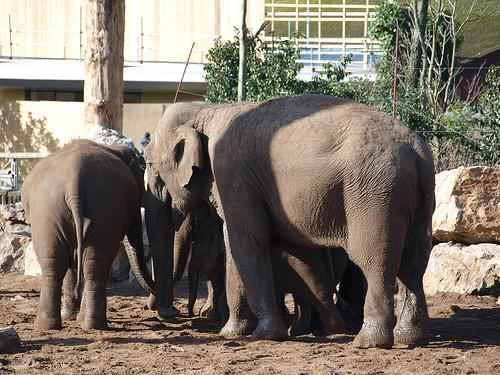Question: what color are the elephants?
Choices:
A. Gray.
B. Silver.
C. White.
D. Brown.
Answer with the letter. Answer: A Question: what type of animals are these?
Choices:
A. Elephants.
B. Dogs.
C. Cats.
D. Tigers.
Answer with the letter. Answer: A Question: where are the trees?
Choices:
A. In front of the elephants.
B. To the left of the elephants.
C. Behind the elephants.
D. To the right of the elephants.
Answer with the letter. Answer: C Question: what color are the tree's leaves?
Choices:
A. Green.
B. Orange.
C. Yellow.
D. Brown.
Answer with the letter. Answer: A Question: what are the elephants walking on?
Choices:
A. Paved road.
B. Escalator.
C. Snow.
D. Dirt.
Answer with the letter. Answer: D 